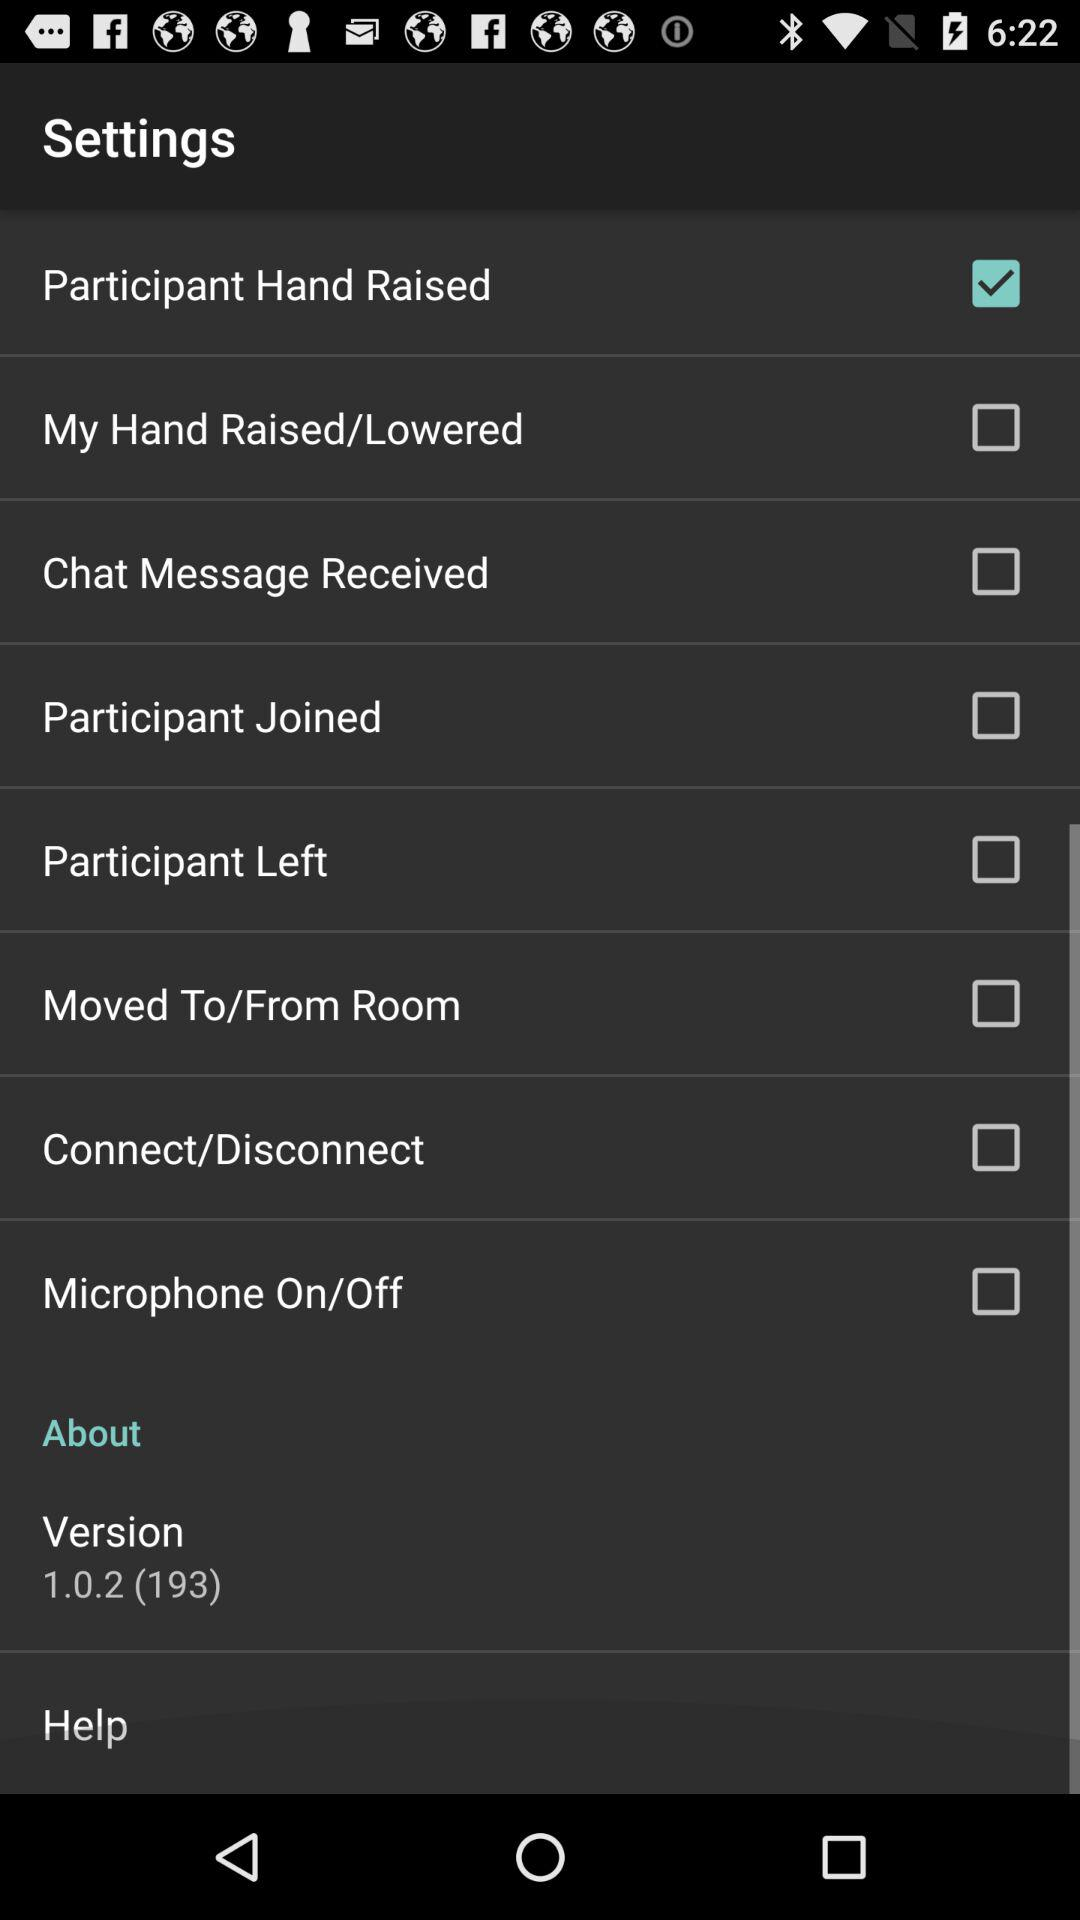How many checkboxes are in the settings menu?
Answer the question using a single word or phrase. 8 